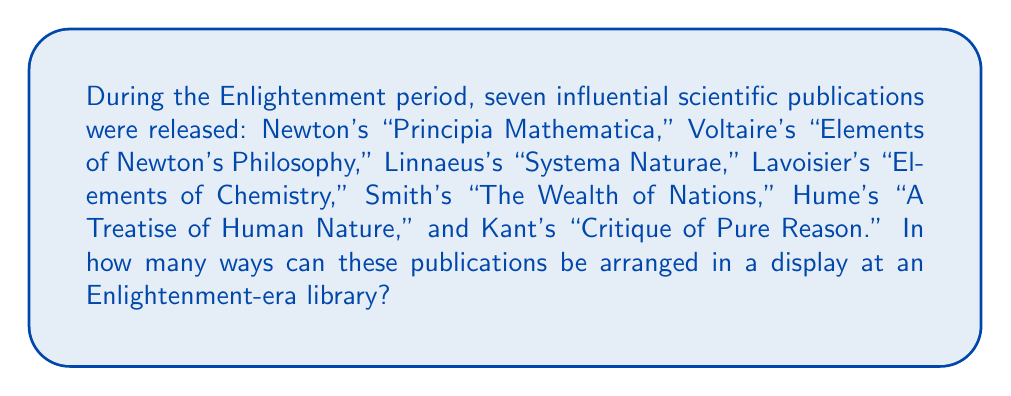Could you help me with this problem? To solve this problem, we need to understand the concept of permutations. A permutation is an arrangement of objects where order matters. In this case, we are arranging 7 distinct publications, and the order of arrangement is important.

The formula for calculating the number of permutations of n distinct objects is:

$$P(n) = n!$$

Where $n!$ (n factorial) is the product of all positive integers less than or equal to n.

In our case, $n = 7$ (the number of publications).

So, we calculate:

$$\begin{align}
P(7) &= 7! \\
&= 7 \times 6 \times 5 \times 4 \times 3 \times 2 \times 1 \\
&= 5040
\end{align}$$

This means there are 5040 different ways to arrange these seven influential Enlightenment-era scientific publications in the library display.
Answer: $5040$ permutations 